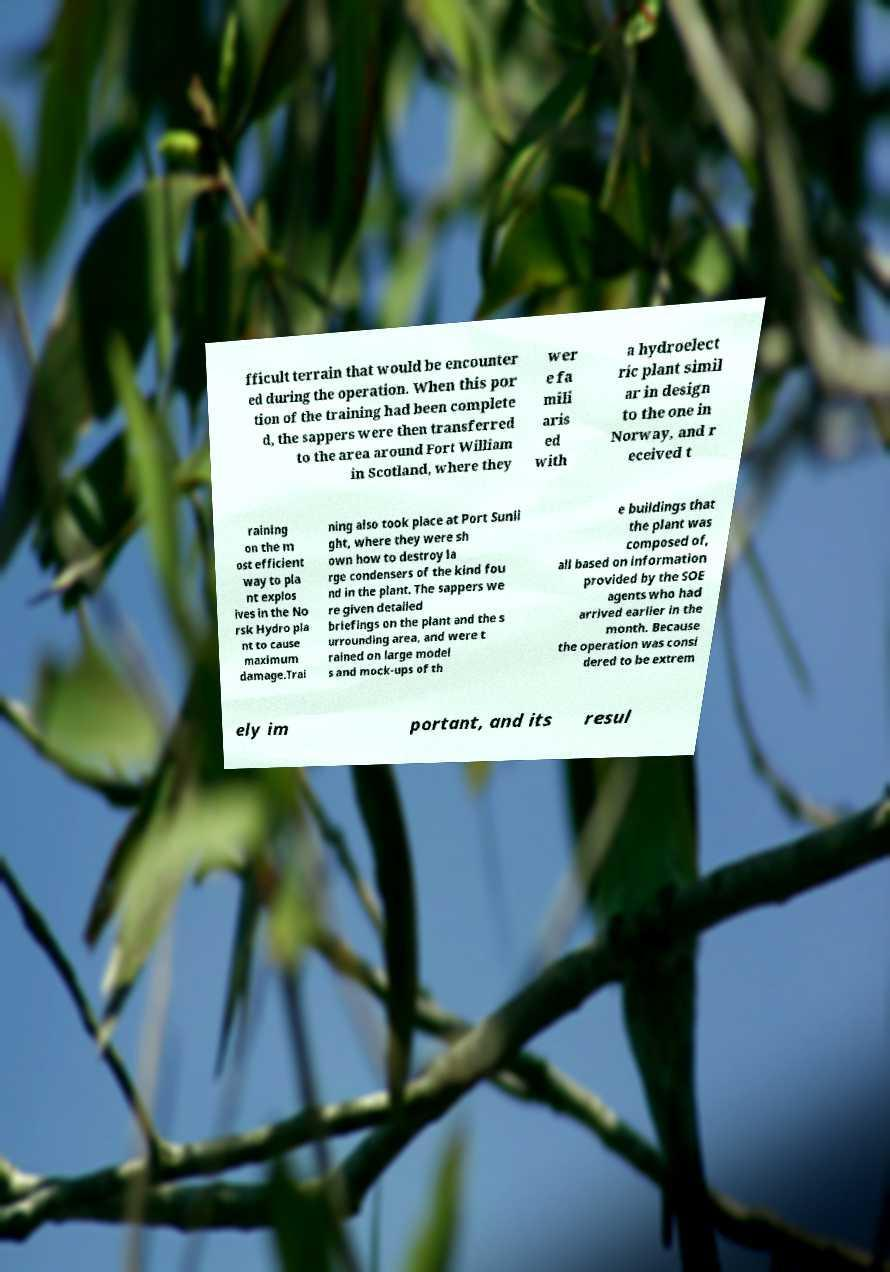For documentation purposes, I need the text within this image transcribed. Could you provide that? fficult terrain that would be encounter ed during the operation. When this por tion of the training had been complete d, the sappers were then transferred to the area around Fort William in Scotland, where they wer e fa mili aris ed with a hydroelect ric plant simil ar in design to the one in Norway, and r eceived t raining on the m ost efficient way to pla nt explos ives in the No rsk Hydro pla nt to cause maximum damage.Trai ning also took place at Port Sunli ght, where they were sh own how to destroy la rge condensers of the kind fou nd in the plant. The sappers we re given detailed briefings on the plant and the s urrounding area, and were t rained on large model s and mock-ups of th e buildings that the plant was composed of, all based on information provided by the SOE agents who had arrived earlier in the month. Because the operation was consi dered to be extrem ely im portant, and its resul 